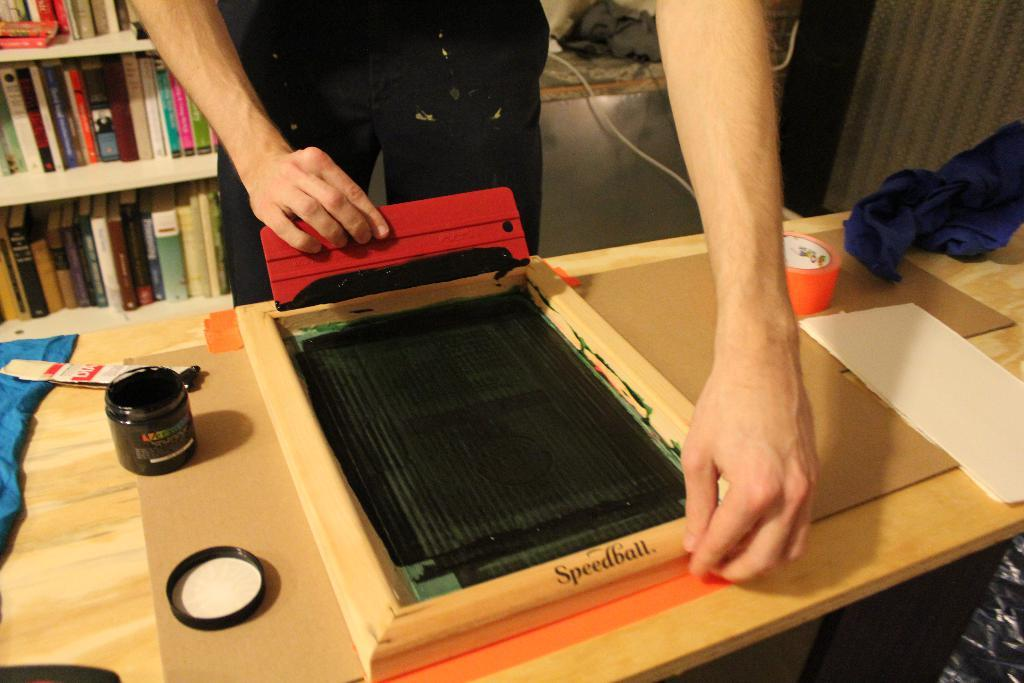What is the main subject in the image? There is a person standing in the image. What object is present near the person? There is a table in the image. What items can be seen on the table? There is a paper, cloth, and an ink pot on the table. What can be seen in the background of the image? There are shelves in the background of the image. What is stored on the shelves? There are books in the shelves. How many brothers does the person in the image have? There is no information about the person's brothers in the image. Can you see a worm crawling on the table in the image? There is no worm present in the image. 